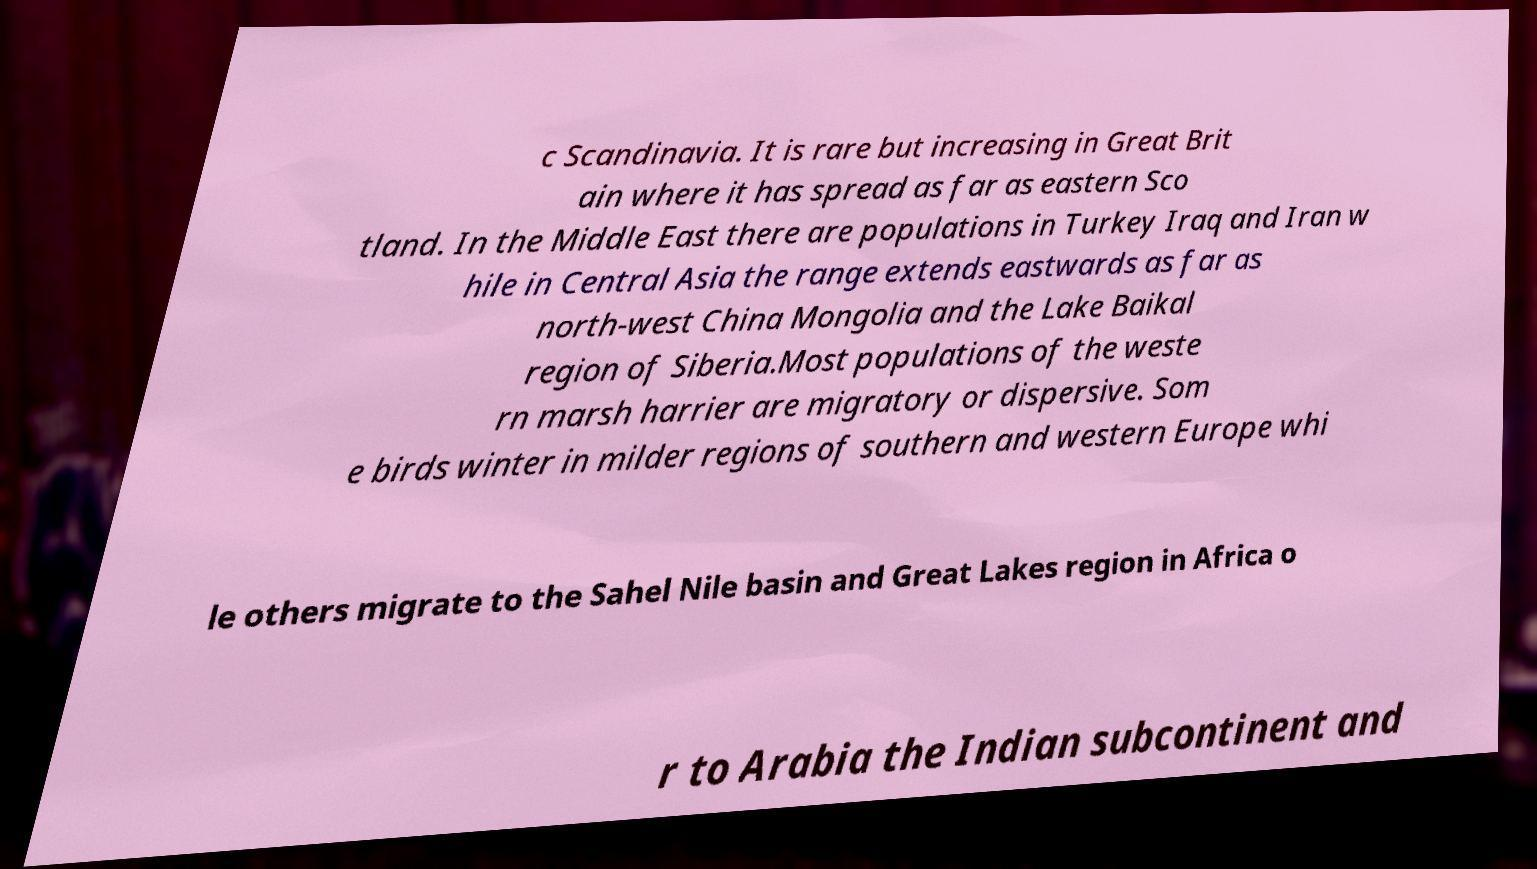Please identify and transcribe the text found in this image. c Scandinavia. It is rare but increasing in Great Brit ain where it has spread as far as eastern Sco tland. In the Middle East there are populations in Turkey Iraq and Iran w hile in Central Asia the range extends eastwards as far as north-west China Mongolia and the Lake Baikal region of Siberia.Most populations of the weste rn marsh harrier are migratory or dispersive. Som e birds winter in milder regions of southern and western Europe whi le others migrate to the Sahel Nile basin and Great Lakes region in Africa o r to Arabia the Indian subcontinent and 